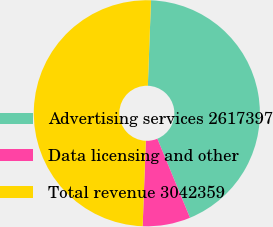<chart> <loc_0><loc_0><loc_500><loc_500><pie_chart><fcel>Advertising services 2617397<fcel>Data licensing and other<fcel>Total revenue 3042359<nl><fcel>43.18%<fcel>6.82%<fcel>50.0%<nl></chart> 